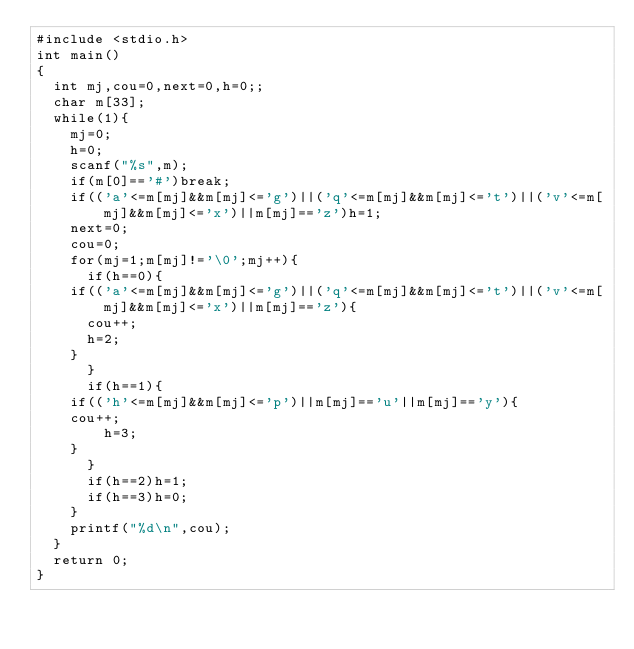<code> <loc_0><loc_0><loc_500><loc_500><_C_>#include <stdio.h>
int main()
{
  int mj,cou=0,next=0,h=0;;
  char m[33];
  while(1){
    mj=0;
    h=0;
    scanf("%s",m);
    if(m[0]=='#')break;
    if(('a'<=m[mj]&&m[mj]<='g')||('q'<=m[mj]&&m[mj]<='t')||('v'<=m[mj]&&m[mj]<='x')||m[mj]=='z')h=1;
    next=0;
    cou=0;
    for(mj=1;m[mj]!='\0';mj++){
      if(h==0){
	if(('a'<=m[mj]&&m[mj]<='g')||('q'<=m[mj]&&m[mj]<='t')||('v'<=m[mj]&&m[mj]<='x')||m[mj]=='z'){
	  cou++;
	  h=2;
	}
      }
      if(h==1){
	if(('h'<=m[mj]&&m[mj]<='p')||m[mj]=='u'||m[mj]=='y'){
	cou++;
        h=3;
	}
      }
      if(h==2)h=1;
      if(h==3)h=0;
    }
    printf("%d\n",cou);
  }
  return 0;
}</code> 